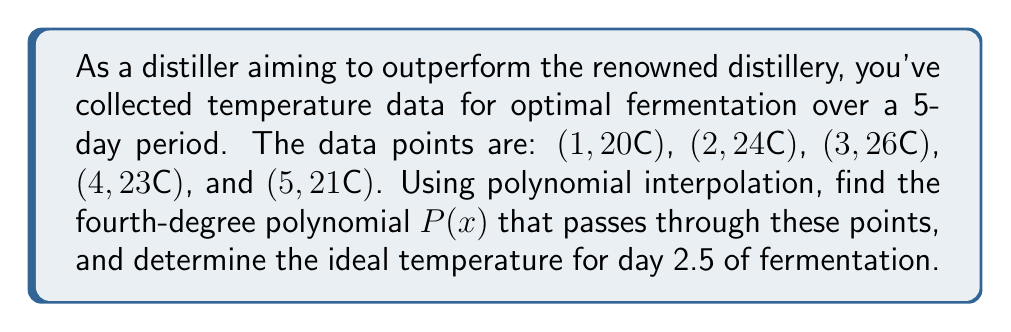Solve this math problem. To solve this problem, we'll use Lagrange interpolation to find the fourth-degree polynomial $P(x)$ that passes through the given points.

Step 1: Set up the Lagrange interpolation formula:
$$P(x) = \sum_{i=1}^{5} y_i \cdot L_i(x)$$
where $L_i(x)$ are the Lagrange basis polynomials.

Step 2: Calculate the Lagrange basis polynomials:
$$L_1(x) = \frac{(x-2)(x-3)(x-4)(x-5)}{(1-2)(1-3)(1-4)(1-5)}$$
$$L_2(x) = \frac{(x-1)(x-3)(x-4)(x-5)}{(2-1)(2-3)(2-4)(2-5)}$$
$$L_3(x) = \frac{(x-1)(x-2)(x-4)(x-5)}{(3-1)(3-2)(3-4)(3-5)}$$
$$L_4(x) = \frac{(x-1)(x-2)(x-3)(x-5)}{(4-1)(4-2)(4-3)(4-5)}$$
$$L_5(x) = \frac{(x-1)(x-2)(x-3)(x-4)}{(5-1)(5-2)(5-3)(5-4)}$$

Step 3: Substitute the $y_i$ values and simplify:
$$P(x) = 20 \cdot L_1(x) + 24 \cdot L_2(x) + 26 \cdot L_3(x) + 23 \cdot L_4(x) + 21 \cdot L_5(x)$$

Step 4: Expand and collect terms to get the polynomial in standard form:
$$P(x) = \frac{1}{24}x^4 - \frac{13}{12}x^3 + \frac{23}{8}x^2 - \frac{45}{24}x + 20$$

Step 5: To find the ideal temperature for day 2.5, evaluate $P(2.5)$:
$$P(2.5) = \frac{1}{24}(2.5)^4 - \frac{13}{12}(2.5)^3 + \frac{23}{8}(2.5)^2 - \frac{45}{24}(2.5) + 20$$
$$P(2.5) \approx 25.2708$$

Therefore, the ideal temperature for day 2.5 of fermentation is approximately 25.27°C.
Answer: $P(x) = \frac{1}{24}x^4 - \frac{13}{12}x^3 + \frac{23}{8}x^2 - \frac{45}{24}x + 20$; 25.27°C 